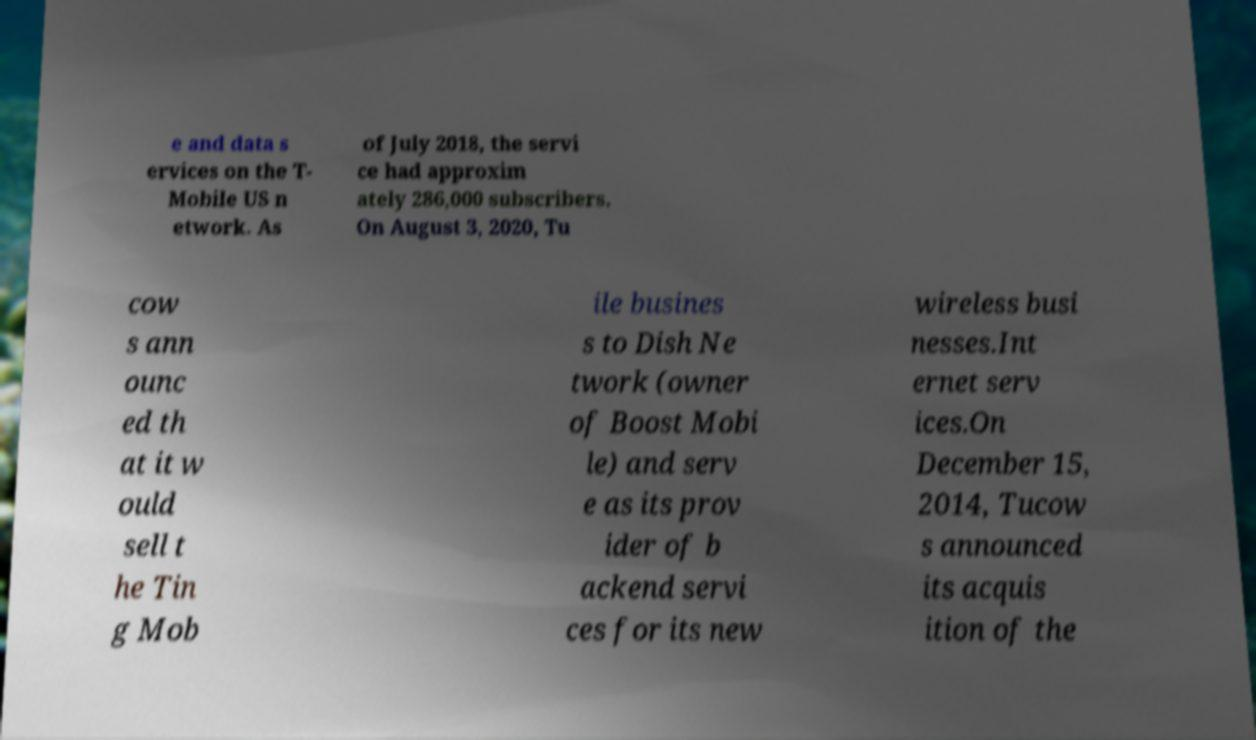For documentation purposes, I need the text within this image transcribed. Could you provide that? e and data s ervices on the T- Mobile US n etwork. As of July 2018, the servi ce had approxim ately 286,000 subscribers. On August 3, 2020, Tu cow s ann ounc ed th at it w ould sell t he Tin g Mob ile busines s to Dish Ne twork (owner of Boost Mobi le) and serv e as its prov ider of b ackend servi ces for its new wireless busi nesses.Int ernet serv ices.On December 15, 2014, Tucow s announced its acquis ition of the 